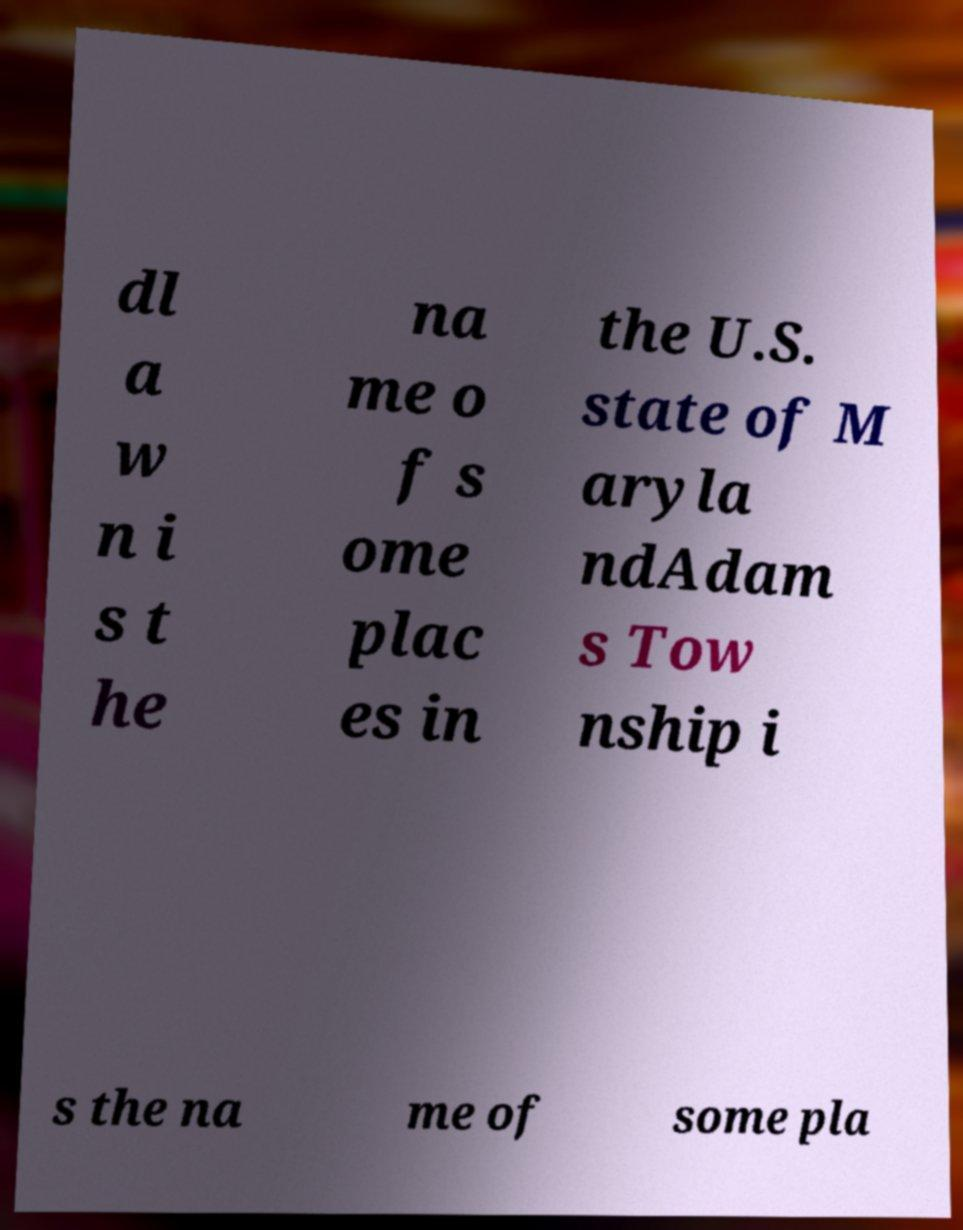For documentation purposes, I need the text within this image transcribed. Could you provide that? dl a w n i s t he na me o f s ome plac es in the U.S. state of M aryla ndAdam s Tow nship i s the na me of some pla 